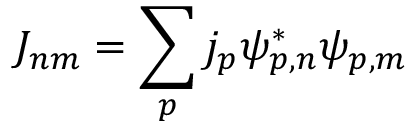<formula> <loc_0><loc_0><loc_500><loc_500>J _ { n m } = \sum _ { p } j _ { p } \psi _ { p , n } ^ { * } \psi _ { p , m }</formula> 